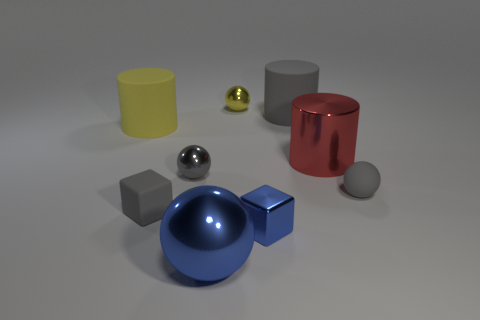Add 1 blue metallic balls. How many objects exist? 10 Subtract all blocks. How many objects are left? 7 Add 8 green matte cylinders. How many green matte cylinders exist? 8 Subtract 0 purple spheres. How many objects are left? 9 Subtract all big gray objects. Subtract all tiny purple cubes. How many objects are left? 8 Add 4 gray matte cylinders. How many gray matte cylinders are left? 5 